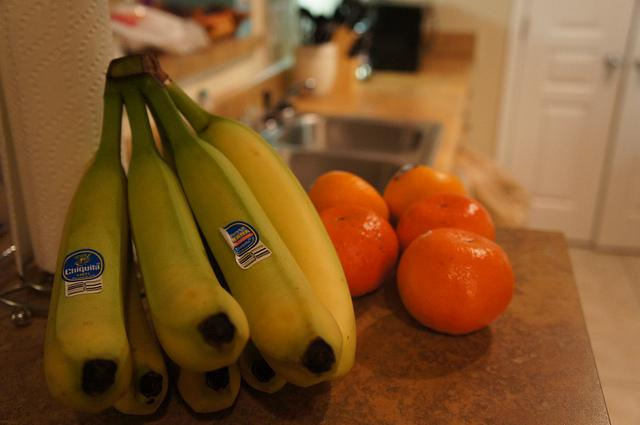What is next to the banana? oranges 